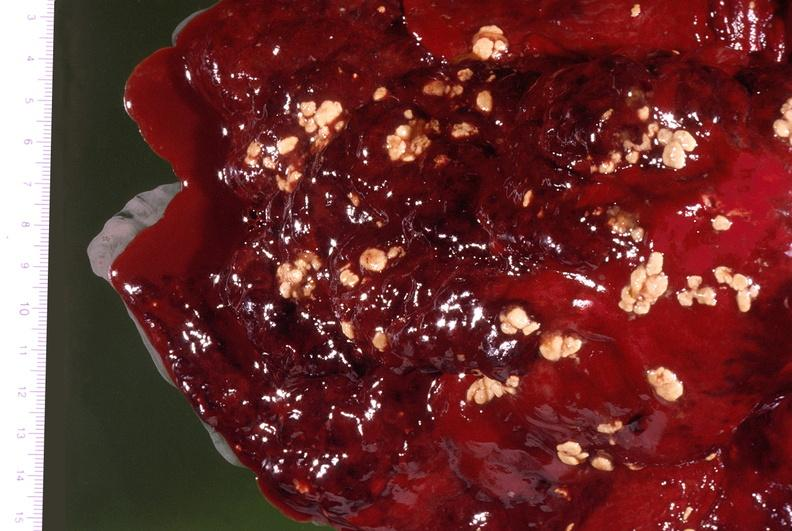what does this image show?
Answer the question using a single word or phrase. Pleural cavity 